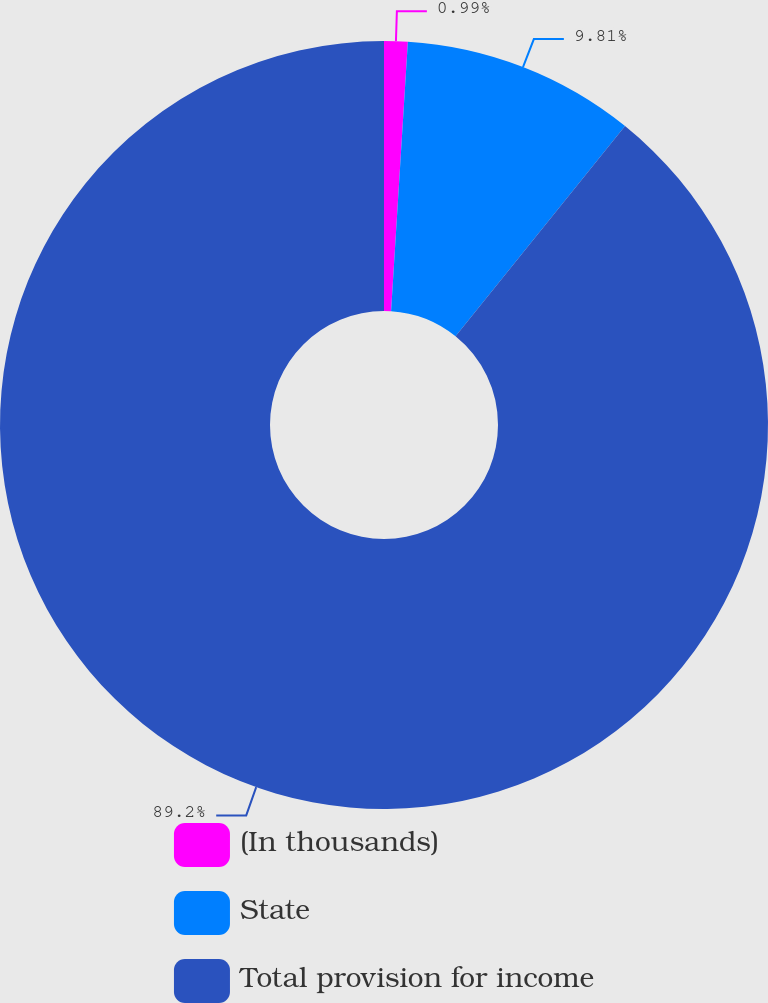Convert chart to OTSL. <chart><loc_0><loc_0><loc_500><loc_500><pie_chart><fcel>(In thousands)<fcel>State<fcel>Total provision for income<nl><fcel>0.99%<fcel>9.81%<fcel>89.2%<nl></chart> 